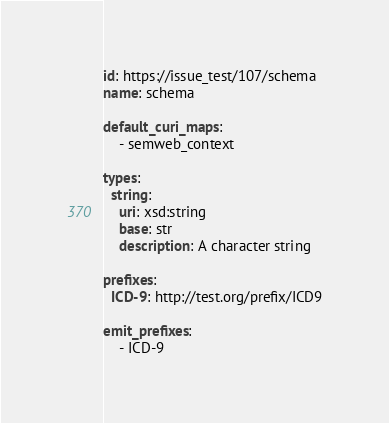<code> <loc_0><loc_0><loc_500><loc_500><_YAML_>id: https://issue_test/107/schema
name: schema

default_curi_maps:
    - semweb_context

types:
  string:
    uri: xsd:string
    base: str
    description: A character string

prefixes:
  ICD-9: http://test.org/prefix/ICD9

emit_prefixes:
    - ICD-9</code> 